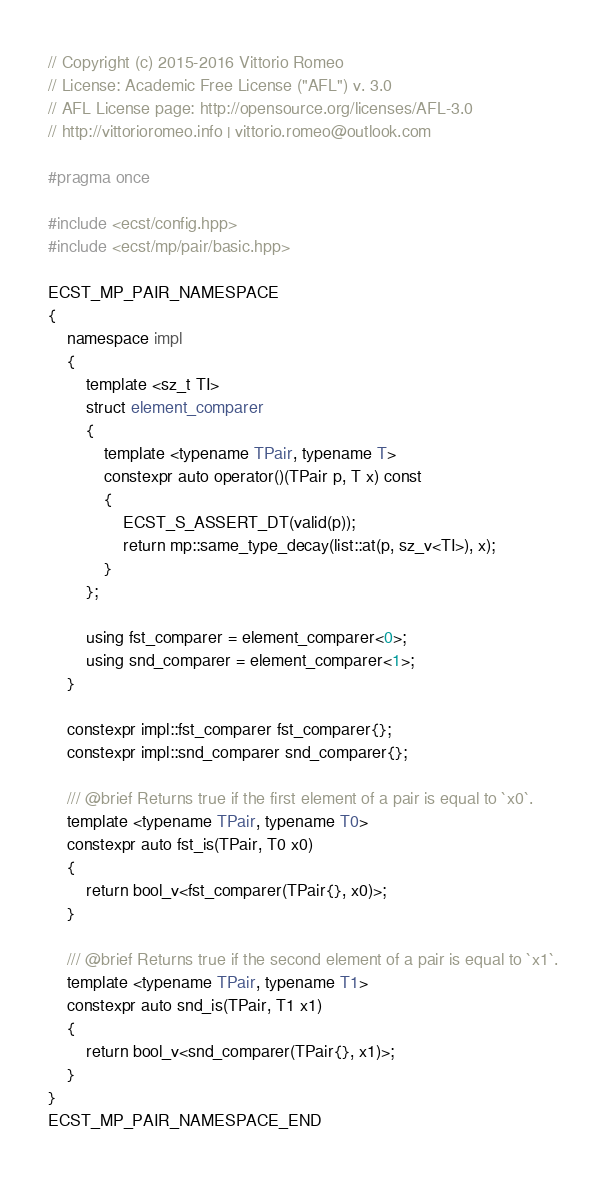Convert code to text. <code><loc_0><loc_0><loc_500><loc_500><_C++_>// Copyright (c) 2015-2016 Vittorio Romeo
// License: Academic Free License ("AFL") v. 3.0
// AFL License page: http://opensource.org/licenses/AFL-3.0
// http://vittorioromeo.info | vittorio.romeo@outlook.com

#pragma once

#include <ecst/config.hpp>
#include <ecst/mp/pair/basic.hpp>

ECST_MP_PAIR_NAMESPACE
{
    namespace impl
    {
        template <sz_t TI>
        struct element_comparer
        {
            template <typename TPair, typename T>
            constexpr auto operator()(TPair p, T x) const
            {
                ECST_S_ASSERT_DT(valid(p));
                return mp::same_type_decay(list::at(p, sz_v<TI>), x);
            }
        };

        using fst_comparer = element_comparer<0>;
        using snd_comparer = element_comparer<1>;
    }

    constexpr impl::fst_comparer fst_comparer{};
    constexpr impl::snd_comparer snd_comparer{};

    /// @brief Returns true if the first element of a pair is equal to `x0`.
    template <typename TPair, typename T0>
    constexpr auto fst_is(TPair, T0 x0)
    {
        return bool_v<fst_comparer(TPair{}, x0)>;
    }

    /// @brief Returns true if the second element of a pair is equal to `x1`.
    template <typename TPair, typename T1>
    constexpr auto snd_is(TPair, T1 x1)
    {
        return bool_v<snd_comparer(TPair{}, x1)>;
    }
}
ECST_MP_PAIR_NAMESPACE_END
</code> 